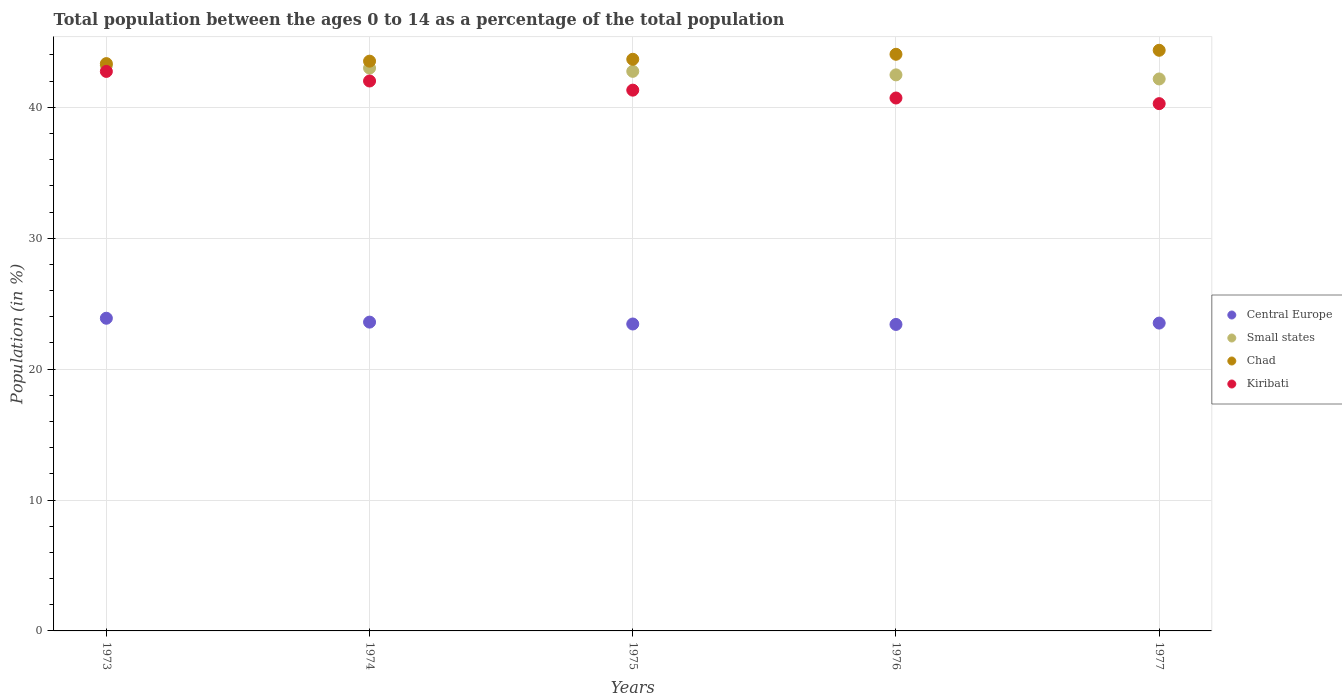Is the number of dotlines equal to the number of legend labels?
Ensure brevity in your answer.  Yes. What is the percentage of the population ages 0 to 14 in Central Europe in 1974?
Keep it short and to the point. 23.59. Across all years, what is the maximum percentage of the population ages 0 to 14 in Small states?
Your response must be concise. 43.19. Across all years, what is the minimum percentage of the population ages 0 to 14 in Central Europe?
Give a very brief answer. 23.41. In which year was the percentage of the population ages 0 to 14 in Central Europe minimum?
Give a very brief answer. 1976. What is the total percentage of the population ages 0 to 14 in Central Europe in the graph?
Offer a terse response. 117.85. What is the difference between the percentage of the population ages 0 to 14 in Small states in 1976 and that in 1977?
Your answer should be compact. 0.31. What is the difference between the percentage of the population ages 0 to 14 in Central Europe in 1975 and the percentage of the population ages 0 to 14 in Kiribati in 1977?
Keep it short and to the point. -16.83. What is the average percentage of the population ages 0 to 14 in Small states per year?
Offer a very short reply. 42.72. In the year 1977, what is the difference between the percentage of the population ages 0 to 14 in Small states and percentage of the population ages 0 to 14 in Central Europe?
Provide a succinct answer. 18.65. What is the ratio of the percentage of the population ages 0 to 14 in Chad in 1975 to that in 1976?
Provide a short and direct response. 0.99. Is the percentage of the population ages 0 to 14 in Small states in 1973 less than that in 1976?
Your answer should be very brief. No. Is the difference between the percentage of the population ages 0 to 14 in Small states in 1973 and 1976 greater than the difference between the percentage of the population ages 0 to 14 in Central Europe in 1973 and 1976?
Offer a very short reply. Yes. What is the difference between the highest and the second highest percentage of the population ages 0 to 14 in Small states?
Offer a very short reply. 0.19. What is the difference between the highest and the lowest percentage of the population ages 0 to 14 in Chad?
Give a very brief answer. 1.02. Is it the case that in every year, the sum of the percentage of the population ages 0 to 14 in Chad and percentage of the population ages 0 to 14 in Kiribati  is greater than the sum of percentage of the population ages 0 to 14 in Central Europe and percentage of the population ages 0 to 14 in Small states?
Your response must be concise. Yes. Is it the case that in every year, the sum of the percentage of the population ages 0 to 14 in Kiribati and percentage of the population ages 0 to 14 in Central Europe  is greater than the percentage of the population ages 0 to 14 in Small states?
Make the answer very short. Yes. What is the difference between two consecutive major ticks on the Y-axis?
Provide a short and direct response. 10. Does the graph contain any zero values?
Make the answer very short. No. Does the graph contain grids?
Offer a terse response. Yes. Where does the legend appear in the graph?
Your answer should be compact. Center right. How many legend labels are there?
Offer a very short reply. 4. How are the legend labels stacked?
Ensure brevity in your answer.  Vertical. What is the title of the graph?
Provide a short and direct response. Total population between the ages 0 to 14 as a percentage of the total population. What is the label or title of the X-axis?
Provide a succinct answer. Years. What is the Population (in %) of Central Europe in 1973?
Offer a very short reply. 23.89. What is the Population (in %) in Small states in 1973?
Keep it short and to the point. 43.19. What is the Population (in %) in Chad in 1973?
Ensure brevity in your answer.  43.34. What is the Population (in %) in Kiribati in 1973?
Your answer should be compact. 42.74. What is the Population (in %) in Central Europe in 1974?
Ensure brevity in your answer.  23.59. What is the Population (in %) in Small states in 1974?
Keep it short and to the point. 43. What is the Population (in %) in Chad in 1974?
Offer a terse response. 43.53. What is the Population (in %) of Kiribati in 1974?
Give a very brief answer. 42.01. What is the Population (in %) of Central Europe in 1975?
Your answer should be very brief. 23.45. What is the Population (in %) in Small states in 1975?
Your response must be concise. 42.75. What is the Population (in %) of Chad in 1975?
Offer a very short reply. 43.67. What is the Population (in %) of Kiribati in 1975?
Provide a succinct answer. 41.31. What is the Population (in %) of Central Europe in 1976?
Your answer should be very brief. 23.41. What is the Population (in %) in Small states in 1976?
Provide a short and direct response. 42.48. What is the Population (in %) of Chad in 1976?
Ensure brevity in your answer.  44.05. What is the Population (in %) in Kiribati in 1976?
Your response must be concise. 40.71. What is the Population (in %) in Central Europe in 1977?
Provide a short and direct response. 23.52. What is the Population (in %) in Small states in 1977?
Offer a terse response. 42.17. What is the Population (in %) in Chad in 1977?
Offer a very short reply. 44.36. What is the Population (in %) in Kiribati in 1977?
Provide a short and direct response. 40.28. Across all years, what is the maximum Population (in %) of Central Europe?
Provide a succinct answer. 23.89. Across all years, what is the maximum Population (in %) of Small states?
Your answer should be compact. 43.19. Across all years, what is the maximum Population (in %) in Chad?
Your answer should be very brief. 44.36. Across all years, what is the maximum Population (in %) in Kiribati?
Your answer should be very brief. 42.74. Across all years, what is the minimum Population (in %) of Central Europe?
Your answer should be very brief. 23.41. Across all years, what is the minimum Population (in %) of Small states?
Keep it short and to the point. 42.17. Across all years, what is the minimum Population (in %) of Chad?
Your answer should be compact. 43.34. Across all years, what is the minimum Population (in %) of Kiribati?
Offer a very short reply. 40.28. What is the total Population (in %) of Central Europe in the graph?
Keep it short and to the point. 117.85. What is the total Population (in %) of Small states in the graph?
Ensure brevity in your answer.  213.58. What is the total Population (in %) of Chad in the graph?
Ensure brevity in your answer.  218.94. What is the total Population (in %) of Kiribati in the graph?
Keep it short and to the point. 207.05. What is the difference between the Population (in %) of Central Europe in 1973 and that in 1974?
Make the answer very short. 0.3. What is the difference between the Population (in %) of Small states in 1973 and that in 1974?
Ensure brevity in your answer.  0.19. What is the difference between the Population (in %) of Chad in 1973 and that in 1974?
Keep it short and to the point. -0.19. What is the difference between the Population (in %) of Kiribati in 1973 and that in 1974?
Your answer should be very brief. 0.73. What is the difference between the Population (in %) of Central Europe in 1973 and that in 1975?
Provide a succinct answer. 0.44. What is the difference between the Population (in %) of Small states in 1973 and that in 1975?
Your answer should be compact. 0.44. What is the difference between the Population (in %) of Chad in 1973 and that in 1975?
Offer a very short reply. -0.33. What is the difference between the Population (in %) in Kiribati in 1973 and that in 1975?
Your response must be concise. 1.43. What is the difference between the Population (in %) of Central Europe in 1973 and that in 1976?
Make the answer very short. 0.47. What is the difference between the Population (in %) of Small states in 1973 and that in 1976?
Your response must be concise. 0.71. What is the difference between the Population (in %) in Chad in 1973 and that in 1976?
Provide a succinct answer. -0.71. What is the difference between the Population (in %) in Kiribati in 1973 and that in 1976?
Offer a terse response. 2.03. What is the difference between the Population (in %) of Central Europe in 1973 and that in 1977?
Your answer should be compact. 0.37. What is the difference between the Population (in %) in Small states in 1973 and that in 1977?
Offer a very short reply. 1.02. What is the difference between the Population (in %) in Chad in 1973 and that in 1977?
Your response must be concise. -1.02. What is the difference between the Population (in %) of Kiribati in 1973 and that in 1977?
Offer a terse response. 2.46. What is the difference between the Population (in %) of Central Europe in 1974 and that in 1975?
Ensure brevity in your answer.  0.14. What is the difference between the Population (in %) of Small states in 1974 and that in 1975?
Make the answer very short. 0.25. What is the difference between the Population (in %) in Chad in 1974 and that in 1975?
Provide a short and direct response. -0.14. What is the difference between the Population (in %) of Kiribati in 1974 and that in 1975?
Your answer should be compact. 0.7. What is the difference between the Population (in %) of Central Europe in 1974 and that in 1976?
Make the answer very short. 0.18. What is the difference between the Population (in %) of Small states in 1974 and that in 1976?
Offer a very short reply. 0.52. What is the difference between the Population (in %) of Chad in 1974 and that in 1976?
Ensure brevity in your answer.  -0.53. What is the difference between the Population (in %) in Kiribati in 1974 and that in 1976?
Provide a succinct answer. 1.3. What is the difference between the Population (in %) in Central Europe in 1974 and that in 1977?
Provide a succinct answer. 0.07. What is the difference between the Population (in %) in Small states in 1974 and that in 1977?
Keep it short and to the point. 0.83. What is the difference between the Population (in %) in Chad in 1974 and that in 1977?
Offer a very short reply. -0.83. What is the difference between the Population (in %) of Kiribati in 1974 and that in 1977?
Your response must be concise. 1.73. What is the difference between the Population (in %) of Small states in 1975 and that in 1976?
Provide a short and direct response. 0.27. What is the difference between the Population (in %) of Chad in 1975 and that in 1976?
Ensure brevity in your answer.  -0.38. What is the difference between the Population (in %) in Kiribati in 1975 and that in 1976?
Your response must be concise. 0.6. What is the difference between the Population (in %) of Central Europe in 1975 and that in 1977?
Ensure brevity in your answer.  -0.07. What is the difference between the Population (in %) in Small states in 1975 and that in 1977?
Your answer should be very brief. 0.58. What is the difference between the Population (in %) of Chad in 1975 and that in 1977?
Offer a very short reply. -0.69. What is the difference between the Population (in %) of Kiribati in 1975 and that in 1977?
Provide a short and direct response. 1.03. What is the difference between the Population (in %) of Central Europe in 1976 and that in 1977?
Ensure brevity in your answer.  -0.1. What is the difference between the Population (in %) in Small states in 1976 and that in 1977?
Offer a very short reply. 0.31. What is the difference between the Population (in %) of Chad in 1976 and that in 1977?
Keep it short and to the point. -0.31. What is the difference between the Population (in %) of Kiribati in 1976 and that in 1977?
Ensure brevity in your answer.  0.43. What is the difference between the Population (in %) in Central Europe in 1973 and the Population (in %) in Small states in 1974?
Ensure brevity in your answer.  -19.11. What is the difference between the Population (in %) of Central Europe in 1973 and the Population (in %) of Chad in 1974?
Ensure brevity in your answer.  -19.64. What is the difference between the Population (in %) in Central Europe in 1973 and the Population (in %) in Kiribati in 1974?
Ensure brevity in your answer.  -18.12. What is the difference between the Population (in %) in Small states in 1973 and the Population (in %) in Chad in 1974?
Keep it short and to the point. -0.34. What is the difference between the Population (in %) in Small states in 1973 and the Population (in %) in Kiribati in 1974?
Offer a terse response. 1.18. What is the difference between the Population (in %) in Chad in 1973 and the Population (in %) in Kiribati in 1974?
Make the answer very short. 1.33. What is the difference between the Population (in %) in Central Europe in 1973 and the Population (in %) in Small states in 1975?
Provide a succinct answer. -18.86. What is the difference between the Population (in %) in Central Europe in 1973 and the Population (in %) in Chad in 1975?
Keep it short and to the point. -19.78. What is the difference between the Population (in %) of Central Europe in 1973 and the Population (in %) of Kiribati in 1975?
Provide a succinct answer. -17.43. What is the difference between the Population (in %) in Small states in 1973 and the Population (in %) in Chad in 1975?
Provide a succinct answer. -0.48. What is the difference between the Population (in %) of Small states in 1973 and the Population (in %) of Kiribati in 1975?
Your answer should be compact. 1.88. What is the difference between the Population (in %) of Chad in 1973 and the Population (in %) of Kiribati in 1975?
Give a very brief answer. 2.03. What is the difference between the Population (in %) in Central Europe in 1973 and the Population (in %) in Small states in 1976?
Your response must be concise. -18.59. What is the difference between the Population (in %) of Central Europe in 1973 and the Population (in %) of Chad in 1976?
Provide a succinct answer. -20.16. What is the difference between the Population (in %) of Central Europe in 1973 and the Population (in %) of Kiribati in 1976?
Offer a very short reply. -16.82. What is the difference between the Population (in %) of Small states in 1973 and the Population (in %) of Chad in 1976?
Your answer should be compact. -0.86. What is the difference between the Population (in %) in Small states in 1973 and the Population (in %) in Kiribati in 1976?
Offer a very short reply. 2.48. What is the difference between the Population (in %) in Chad in 1973 and the Population (in %) in Kiribati in 1976?
Offer a very short reply. 2.63. What is the difference between the Population (in %) in Central Europe in 1973 and the Population (in %) in Small states in 1977?
Your answer should be compact. -18.28. What is the difference between the Population (in %) of Central Europe in 1973 and the Population (in %) of Chad in 1977?
Offer a terse response. -20.47. What is the difference between the Population (in %) of Central Europe in 1973 and the Population (in %) of Kiribati in 1977?
Provide a short and direct response. -16.39. What is the difference between the Population (in %) in Small states in 1973 and the Population (in %) in Chad in 1977?
Your answer should be compact. -1.17. What is the difference between the Population (in %) of Small states in 1973 and the Population (in %) of Kiribati in 1977?
Provide a succinct answer. 2.91. What is the difference between the Population (in %) in Chad in 1973 and the Population (in %) in Kiribati in 1977?
Ensure brevity in your answer.  3.06. What is the difference between the Population (in %) of Central Europe in 1974 and the Population (in %) of Small states in 1975?
Keep it short and to the point. -19.16. What is the difference between the Population (in %) in Central Europe in 1974 and the Population (in %) in Chad in 1975?
Offer a very short reply. -20.08. What is the difference between the Population (in %) in Central Europe in 1974 and the Population (in %) in Kiribati in 1975?
Provide a succinct answer. -17.72. What is the difference between the Population (in %) of Small states in 1974 and the Population (in %) of Chad in 1975?
Your response must be concise. -0.67. What is the difference between the Population (in %) in Small states in 1974 and the Population (in %) in Kiribati in 1975?
Make the answer very short. 1.69. What is the difference between the Population (in %) in Chad in 1974 and the Population (in %) in Kiribati in 1975?
Your answer should be compact. 2.21. What is the difference between the Population (in %) in Central Europe in 1974 and the Population (in %) in Small states in 1976?
Ensure brevity in your answer.  -18.89. What is the difference between the Population (in %) in Central Europe in 1974 and the Population (in %) in Chad in 1976?
Offer a very short reply. -20.46. What is the difference between the Population (in %) in Central Europe in 1974 and the Population (in %) in Kiribati in 1976?
Your answer should be very brief. -17.12. What is the difference between the Population (in %) in Small states in 1974 and the Population (in %) in Chad in 1976?
Offer a terse response. -1.05. What is the difference between the Population (in %) of Small states in 1974 and the Population (in %) of Kiribati in 1976?
Keep it short and to the point. 2.29. What is the difference between the Population (in %) in Chad in 1974 and the Population (in %) in Kiribati in 1976?
Give a very brief answer. 2.81. What is the difference between the Population (in %) in Central Europe in 1974 and the Population (in %) in Small states in 1977?
Your answer should be compact. -18.58. What is the difference between the Population (in %) in Central Europe in 1974 and the Population (in %) in Chad in 1977?
Give a very brief answer. -20.77. What is the difference between the Population (in %) of Central Europe in 1974 and the Population (in %) of Kiribati in 1977?
Provide a succinct answer. -16.69. What is the difference between the Population (in %) in Small states in 1974 and the Population (in %) in Chad in 1977?
Your answer should be very brief. -1.36. What is the difference between the Population (in %) in Small states in 1974 and the Population (in %) in Kiribati in 1977?
Your response must be concise. 2.72. What is the difference between the Population (in %) of Chad in 1974 and the Population (in %) of Kiribati in 1977?
Offer a terse response. 3.25. What is the difference between the Population (in %) in Central Europe in 1975 and the Population (in %) in Small states in 1976?
Your response must be concise. -19.03. What is the difference between the Population (in %) in Central Europe in 1975 and the Population (in %) in Chad in 1976?
Give a very brief answer. -20.6. What is the difference between the Population (in %) in Central Europe in 1975 and the Population (in %) in Kiribati in 1976?
Your response must be concise. -17.26. What is the difference between the Population (in %) in Small states in 1975 and the Population (in %) in Chad in 1976?
Provide a succinct answer. -1.3. What is the difference between the Population (in %) of Small states in 1975 and the Population (in %) of Kiribati in 1976?
Provide a succinct answer. 2.04. What is the difference between the Population (in %) of Chad in 1975 and the Population (in %) of Kiribati in 1976?
Provide a short and direct response. 2.96. What is the difference between the Population (in %) of Central Europe in 1975 and the Population (in %) of Small states in 1977?
Your answer should be compact. -18.72. What is the difference between the Population (in %) in Central Europe in 1975 and the Population (in %) in Chad in 1977?
Ensure brevity in your answer.  -20.91. What is the difference between the Population (in %) of Central Europe in 1975 and the Population (in %) of Kiribati in 1977?
Provide a short and direct response. -16.83. What is the difference between the Population (in %) of Small states in 1975 and the Population (in %) of Chad in 1977?
Provide a short and direct response. -1.61. What is the difference between the Population (in %) in Small states in 1975 and the Population (in %) in Kiribati in 1977?
Your answer should be compact. 2.47. What is the difference between the Population (in %) in Chad in 1975 and the Population (in %) in Kiribati in 1977?
Provide a succinct answer. 3.39. What is the difference between the Population (in %) in Central Europe in 1976 and the Population (in %) in Small states in 1977?
Give a very brief answer. -18.75. What is the difference between the Population (in %) in Central Europe in 1976 and the Population (in %) in Chad in 1977?
Provide a short and direct response. -20.94. What is the difference between the Population (in %) of Central Europe in 1976 and the Population (in %) of Kiribati in 1977?
Keep it short and to the point. -16.87. What is the difference between the Population (in %) in Small states in 1976 and the Population (in %) in Chad in 1977?
Offer a terse response. -1.88. What is the difference between the Population (in %) of Small states in 1976 and the Population (in %) of Kiribati in 1977?
Provide a succinct answer. 2.2. What is the difference between the Population (in %) of Chad in 1976 and the Population (in %) of Kiribati in 1977?
Make the answer very short. 3.77. What is the average Population (in %) in Central Europe per year?
Your answer should be very brief. 23.57. What is the average Population (in %) of Small states per year?
Your response must be concise. 42.72. What is the average Population (in %) of Chad per year?
Offer a terse response. 43.79. What is the average Population (in %) in Kiribati per year?
Provide a short and direct response. 41.41. In the year 1973, what is the difference between the Population (in %) of Central Europe and Population (in %) of Small states?
Ensure brevity in your answer.  -19.3. In the year 1973, what is the difference between the Population (in %) of Central Europe and Population (in %) of Chad?
Your answer should be compact. -19.45. In the year 1973, what is the difference between the Population (in %) in Central Europe and Population (in %) in Kiribati?
Make the answer very short. -18.86. In the year 1973, what is the difference between the Population (in %) of Small states and Population (in %) of Chad?
Give a very brief answer. -0.15. In the year 1973, what is the difference between the Population (in %) of Small states and Population (in %) of Kiribati?
Provide a short and direct response. 0.45. In the year 1973, what is the difference between the Population (in %) of Chad and Population (in %) of Kiribati?
Ensure brevity in your answer.  0.6. In the year 1974, what is the difference between the Population (in %) in Central Europe and Population (in %) in Small states?
Keep it short and to the point. -19.41. In the year 1974, what is the difference between the Population (in %) of Central Europe and Population (in %) of Chad?
Make the answer very short. -19.93. In the year 1974, what is the difference between the Population (in %) of Central Europe and Population (in %) of Kiribati?
Offer a terse response. -18.42. In the year 1974, what is the difference between the Population (in %) in Small states and Population (in %) in Chad?
Make the answer very short. -0.53. In the year 1974, what is the difference between the Population (in %) in Small states and Population (in %) in Kiribati?
Your response must be concise. 0.99. In the year 1974, what is the difference between the Population (in %) in Chad and Population (in %) in Kiribati?
Offer a terse response. 1.52. In the year 1975, what is the difference between the Population (in %) of Central Europe and Population (in %) of Small states?
Offer a very short reply. -19.3. In the year 1975, what is the difference between the Population (in %) of Central Europe and Population (in %) of Chad?
Make the answer very short. -20.22. In the year 1975, what is the difference between the Population (in %) in Central Europe and Population (in %) in Kiribati?
Provide a short and direct response. -17.86. In the year 1975, what is the difference between the Population (in %) in Small states and Population (in %) in Chad?
Your answer should be very brief. -0.92. In the year 1975, what is the difference between the Population (in %) in Small states and Population (in %) in Kiribati?
Give a very brief answer. 1.44. In the year 1975, what is the difference between the Population (in %) in Chad and Population (in %) in Kiribati?
Provide a succinct answer. 2.36. In the year 1976, what is the difference between the Population (in %) of Central Europe and Population (in %) of Small states?
Your response must be concise. -19.07. In the year 1976, what is the difference between the Population (in %) of Central Europe and Population (in %) of Chad?
Keep it short and to the point. -20.64. In the year 1976, what is the difference between the Population (in %) of Central Europe and Population (in %) of Kiribati?
Make the answer very short. -17.3. In the year 1976, what is the difference between the Population (in %) in Small states and Population (in %) in Chad?
Your response must be concise. -1.57. In the year 1976, what is the difference between the Population (in %) of Small states and Population (in %) of Kiribati?
Offer a terse response. 1.77. In the year 1976, what is the difference between the Population (in %) of Chad and Population (in %) of Kiribati?
Keep it short and to the point. 3.34. In the year 1977, what is the difference between the Population (in %) of Central Europe and Population (in %) of Small states?
Provide a succinct answer. -18.65. In the year 1977, what is the difference between the Population (in %) in Central Europe and Population (in %) in Chad?
Provide a succinct answer. -20.84. In the year 1977, what is the difference between the Population (in %) of Central Europe and Population (in %) of Kiribati?
Your response must be concise. -16.76. In the year 1977, what is the difference between the Population (in %) of Small states and Population (in %) of Chad?
Provide a succinct answer. -2.19. In the year 1977, what is the difference between the Population (in %) in Small states and Population (in %) in Kiribati?
Provide a succinct answer. 1.89. In the year 1977, what is the difference between the Population (in %) of Chad and Population (in %) of Kiribati?
Your answer should be very brief. 4.08. What is the ratio of the Population (in %) of Central Europe in 1973 to that in 1974?
Provide a succinct answer. 1.01. What is the ratio of the Population (in %) of Chad in 1973 to that in 1974?
Provide a succinct answer. 1. What is the ratio of the Population (in %) of Kiribati in 1973 to that in 1974?
Provide a succinct answer. 1.02. What is the ratio of the Population (in %) of Central Europe in 1973 to that in 1975?
Your answer should be compact. 1.02. What is the ratio of the Population (in %) in Small states in 1973 to that in 1975?
Your response must be concise. 1.01. What is the ratio of the Population (in %) of Chad in 1973 to that in 1975?
Make the answer very short. 0.99. What is the ratio of the Population (in %) in Kiribati in 1973 to that in 1975?
Your answer should be compact. 1.03. What is the ratio of the Population (in %) of Central Europe in 1973 to that in 1976?
Provide a succinct answer. 1.02. What is the ratio of the Population (in %) in Small states in 1973 to that in 1976?
Give a very brief answer. 1.02. What is the ratio of the Population (in %) of Chad in 1973 to that in 1976?
Provide a succinct answer. 0.98. What is the ratio of the Population (in %) of Kiribati in 1973 to that in 1976?
Give a very brief answer. 1.05. What is the ratio of the Population (in %) of Central Europe in 1973 to that in 1977?
Provide a succinct answer. 1.02. What is the ratio of the Population (in %) of Small states in 1973 to that in 1977?
Offer a terse response. 1.02. What is the ratio of the Population (in %) in Chad in 1973 to that in 1977?
Make the answer very short. 0.98. What is the ratio of the Population (in %) of Kiribati in 1973 to that in 1977?
Your response must be concise. 1.06. What is the ratio of the Population (in %) in Chad in 1974 to that in 1975?
Keep it short and to the point. 1. What is the ratio of the Population (in %) in Kiribati in 1974 to that in 1975?
Make the answer very short. 1.02. What is the ratio of the Population (in %) in Central Europe in 1974 to that in 1976?
Your answer should be compact. 1.01. What is the ratio of the Population (in %) in Small states in 1974 to that in 1976?
Provide a short and direct response. 1.01. What is the ratio of the Population (in %) of Chad in 1974 to that in 1976?
Make the answer very short. 0.99. What is the ratio of the Population (in %) of Kiribati in 1974 to that in 1976?
Provide a short and direct response. 1.03. What is the ratio of the Population (in %) of Central Europe in 1974 to that in 1977?
Offer a terse response. 1. What is the ratio of the Population (in %) of Small states in 1974 to that in 1977?
Offer a terse response. 1.02. What is the ratio of the Population (in %) in Chad in 1974 to that in 1977?
Your answer should be compact. 0.98. What is the ratio of the Population (in %) in Kiribati in 1974 to that in 1977?
Give a very brief answer. 1.04. What is the ratio of the Population (in %) in Central Europe in 1975 to that in 1976?
Make the answer very short. 1. What is the ratio of the Population (in %) in Small states in 1975 to that in 1976?
Give a very brief answer. 1.01. What is the ratio of the Population (in %) in Kiribati in 1975 to that in 1976?
Make the answer very short. 1.01. What is the ratio of the Population (in %) of Small states in 1975 to that in 1977?
Provide a succinct answer. 1.01. What is the ratio of the Population (in %) in Chad in 1975 to that in 1977?
Keep it short and to the point. 0.98. What is the ratio of the Population (in %) in Kiribati in 1975 to that in 1977?
Provide a succinct answer. 1.03. What is the ratio of the Population (in %) in Small states in 1976 to that in 1977?
Ensure brevity in your answer.  1.01. What is the ratio of the Population (in %) of Chad in 1976 to that in 1977?
Your response must be concise. 0.99. What is the ratio of the Population (in %) in Kiribati in 1976 to that in 1977?
Ensure brevity in your answer.  1.01. What is the difference between the highest and the second highest Population (in %) of Central Europe?
Provide a short and direct response. 0.3. What is the difference between the highest and the second highest Population (in %) in Small states?
Ensure brevity in your answer.  0.19. What is the difference between the highest and the second highest Population (in %) in Chad?
Ensure brevity in your answer.  0.31. What is the difference between the highest and the second highest Population (in %) in Kiribati?
Give a very brief answer. 0.73. What is the difference between the highest and the lowest Population (in %) in Central Europe?
Your answer should be very brief. 0.47. What is the difference between the highest and the lowest Population (in %) in Small states?
Your answer should be very brief. 1.02. What is the difference between the highest and the lowest Population (in %) of Chad?
Offer a terse response. 1.02. What is the difference between the highest and the lowest Population (in %) of Kiribati?
Provide a succinct answer. 2.46. 